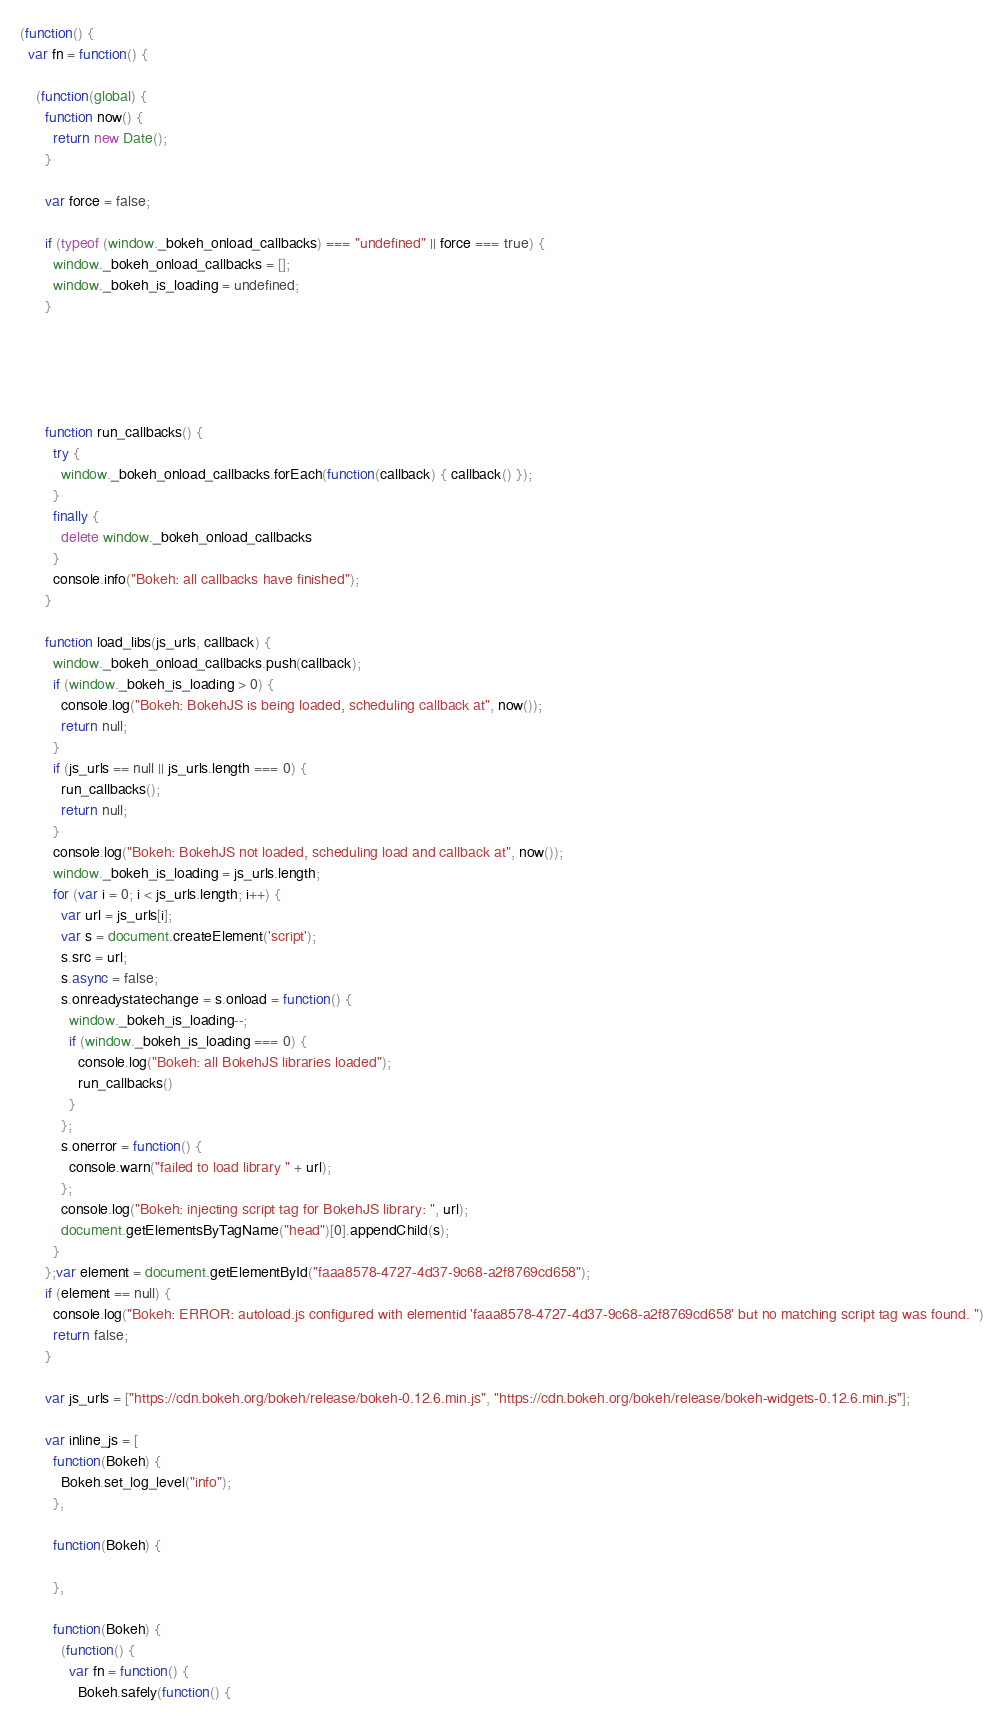<code> <loc_0><loc_0><loc_500><loc_500><_JavaScript_>(function() {
  var fn = function() {
    
    (function(global) {
      function now() {
        return new Date();
      }
    
      var force = false;
    
      if (typeof (window._bokeh_onload_callbacks) === "undefined" || force === true) {
        window._bokeh_onload_callbacks = [];
        window._bokeh_is_loading = undefined;
      }
    
    
      
      
    
      function run_callbacks() {
        try {
          window._bokeh_onload_callbacks.forEach(function(callback) { callback() });
        }
        finally {
          delete window._bokeh_onload_callbacks
        }
        console.info("Bokeh: all callbacks have finished");
      }
    
      function load_libs(js_urls, callback) {
        window._bokeh_onload_callbacks.push(callback);
        if (window._bokeh_is_loading > 0) {
          console.log("Bokeh: BokehJS is being loaded, scheduling callback at", now());
          return null;
        }
        if (js_urls == null || js_urls.length === 0) {
          run_callbacks();
          return null;
        }
        console.log("Bokeh: BokehJS not loaded, scheduling load and callback at", now());
        window._bokeh_is_loading = js_urls.length;
        for (var i = 0; i < js_urls.length; i++) {
          var url = js_urls[i];
          var s = document.createElement('script');
          s.src = url;
          s.async = false;
          s.onreadystatechange = s.onload = function() {
            window._bokeh_is_loading--;
            if (window._bokeh_is_loading === 0) {
              console.log("Bokeh: all BokehJS libraries loaded");
              run_callbacks()
            }
          };
          s.onerror = function() {
            console.warn("failed to load library " + url);
          };
          console.log("Bokeh: injecting script tag for BokehJS library: ", url);
          document.getElementsByTagName("head")[0].appendChild(s);
        }
      };var element = document.getElementById("faaa8578-4727-4d37-9c68-a2f8769cd658");
      if (element == null) {
        console.log("Bokeh: ERROR: autoload.js configured with elementid 'faaa8578-4727-4d37-9c68-a2f8769cd658' but no matching script tag was found. ")
        return false;
      }
    
      var js_urls = ["https://cdn.bokeh.org/bokeh/release/bokeh-0.12.6.min.js", "https://cdn.bokeh.org/bokeh/release/bokeh-widgets-0.12.6.min.js"];
    
      var inline_js = [
        function(Bokeh) {
          Bokeh.set_log_level("info");
        },
        
        function(Bokeh) {
          
        },
        
        function(Bokeh) {
          (function() {
            var fn = function() {
              Bokeh.safely(function() {</code> 